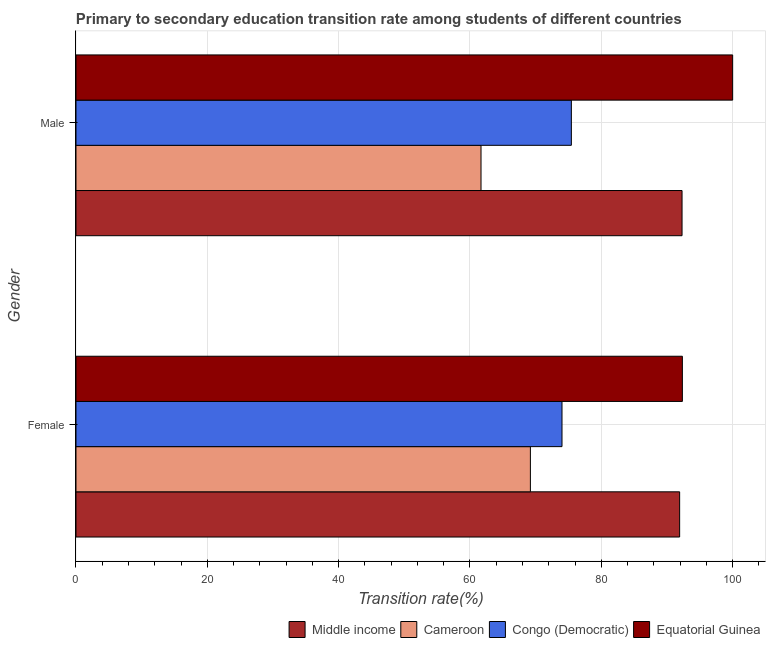Are the number of bars per tick equal to the number of legend labels?
Keep it short and to the point. Yes. How many bars are there on the 1st tick from the bottom?
Ensure brevity in your answer.  4. What is the transition rate among male students in Congo (Democratic)?
Ensure brevity in your answer.  75.44. Across all countries, what is the minimum transition rate among female students?
Your response must be concise. 69.2. In which country was the transition rate among female students maximum?
Keep it short and to the point. Equatorial Guinea. In which country was the transition rate among female students minimum?
Ensure brevity in your answer.  Cameroon. What is the total transition rate among male students in the graph?
Provide a succinct answer. 329.41. What is the difference between the transition rate among female students in Equatorial Guinea and that in Cameroon?
Keep it short and to the point. 23.14. What is the difference between the transition rate among female students in Cameroon and the transition rate among male students in Equatorial Guinea?
Your answer should be compact. -30.8. What is the average transition rate among male students per country?
Make the answer very short. 82.35. What is the difference between the transition rate among female students and transition rate among male students in Cameroon?
Your answer should be very brief. 7.52. In how many countries, is the transition rate among female students greater than 64 %?
Make the answer very short. 4. What is the ratio of the transition rate among male students in Congo (Democratic) to that in Cameroon?
Offer a very short reply. 1.22. Is the transition rate among male students in Middle income less than that in Equatorial Guinea?
Your answer should be compact. Yes. In how many countries, is the transition rate among male students greater than the average transition rate among male students taken over all countries?
Keep it short and to the point. 2. What does the 3rd bar from the top in Female represents?
Give a very brief answer. Cameroon. What does the 2nd bar from the bottom in Male represents?
Your answer should be compact. Cameroon. What is the difference between two consecutive major ticks on the X-axis?
Keep it short and to the point. 20. Where does the legend appear in the graph?
Keep it short and to the point. Bottom right. How many legend labels are there?
Offer a very short reply. 4. What is the title of the graph?
Your response must be concise. Primary to secondary education transition rate among students of different countries. Does "Europe(all income levels)" appear as one of the legend labels in the graph?
Keep it short and to the point. No. What is the label or title of the X-axis?
Your answer should be very brief. Transition rate(%). What is the Transition rate(%) in Middle income in Female?
Offer a terse response. 91.93. What is the Transition rate(%) of Cameroon in Female?
Keep it short and to the point. 69.2. What is the Transition rate(%) of Congo (Democratic) in Female?
Ensure brevity in your answer.  74.01. What is the Transition rate(%) in Equatorial Guinea in Female?
Offer a very short reply. 92.34. What is the Transition rate(%) of Middle income in Male?
Provide a short and direct response. 92.29. What is the Transition rate(%) of Cameroon in Male?
Ensure brevity in your answer.  61.68. What is the Transition rate(%) of Congo (Democratic) in Male?
Your response must be concise. 75.44. Across all Gender, what is the maximum Transition rate(%) in Middle income?
Offer a very short reply. 92.29. Across all Gender, what is the maximum Transition rate(%) in Cameroon?
Keep it short and to the point. 69.2. Across all Gender, what is the maximum Transition rate(%) in Congo (Democratic)?
Offer a terse response. 75.44. Across all Gender, what is the maximum Transition rate(%) of Equatorial Guinea?
Make the answer very short. 100. Across all Gender, what is the minimum Transition rate(%) of Middle income?
Offer a very short reply. 91.93. Across all Gender, what is the minimum Transition rate(%) in Cameroon?
Offer a very short reply. 61.68. Across all Gender, what is the minimum Transition rate(%) of Congo (Democratic)?
Give a very brief answer. 74.01. Across all Gender, what is the minimum Transition rate(%) in Equatorial Guinea?
Keep it short and to the point. 92.34. What is the total Transition rate(%) in Middle income in the graph?
Keep it short and to the point. 184.22. What is the total Transition rate(%) in Cameroon in the graph?
Make the answer very short. 130.88. What is the total Transition rate(%) in Congo (Democratic) in the graph?
Provide a succinct answer. 149.45. What is the total Transition rate(%) of Equatorial Guinea in the graph?
Your response must be concise. 192.34. What is the difference between the Transition rate(%) of Middle income in Female and that in Male?
Your answer should be compact. -0.36. What is the difference between the Transition rate(%) in Cameroon in Female and that in Male?
Provide a short and direct response. 7.52. What is the difference between the Transition rate(%) in Congo (Democratic) in Female and that in Male?
Provide a short and direct response. -1.43. What is the difference between the Transition rate(%) of Equatorial Guinea in Female and that in Male?
Offer a terse response. -7.66. What is the difference between the Transition rate(%) of Middle income in Female and the Transition rate(%) of Cameroon in Male?
Provide a succinct answer. 30.25. What is the difference between the Transition rate(%) of Middle income in Female and the Transition rate(%) of Congo (Democratic) in Male?
Your response must be concise. 16.49. What is the difference between the Transition rate(%) in Middle income in Female and the Transition rate(%) in Equatorial Guinea in Male?
Provide a short and direct response. -8.07. What is the difference between the Transition rate(%) of Cameroon in Female and the Transition rate(%) of Congo (Democratic) in Male?
Offer a very short reply. -6.24. What is the difference between the Transition rate(%) of Cameroon in Female and the Transition rate(%) of Equatorial Guinea in Male?
Give a very brief answer. -30.8. What is the difference between the Transition rate(%) in Congo (Democratic) in Female and the Transition rate(%) in Equatorial Guinea in Male?
Provide a short and direct response. -25.99. What is the average Transition rate(%) in Middle income per Gender?
Make the answer very short. 92.11. What is the average Transition rate(%) in Cameroon per Gender?
Keep it short and to the point. 65.44. What is the average Transition rate(%) in Congo (Democratic) per Gender?
Your answer should be very brief. 74.72. What is the average Transition rate(%) in Equatorial Guinea per Gender?
Your response must be concise. 96.17. What is the difference between the Transition rate(%) in Middle income and Transition rate(%) in Cameroon in Female?
Your answer should be very brief. 22.73. What is the difference between the Transition rate(%) in Middle income and Transition rate(%) in Congo (Democratic) in Female?
Your response must be concise. 17.92. What is the difference between the Transition rate(%) in Middle income and Transition rate(%) in Equatorial Guinea in Female?
Your response must be concise. -0.42. What is the difference between the Transition rate(%) in Cameroon and Transition rate(%) in Congo (Democratic) in Female?
Your answer should be compact. -4.81. What is the difference between the Transition rate(%) of Cameroon and Transition rate(%) of Equatorial Guinea in Female?
Give a very brief answer. -23.14. What is the difference between the Transition rate(%) of Congo (Democratic) and Transition rate(%) of Equatorial Guinea in Female?
Offer a very short reply. -18.33. What is the difference between the Transition rate(%) in Middle income and Transition rate(%) in Cameroon in Male?
Provide a short and direct response. 30.61. What is the difference between the Transition rate(%) of Middle income and Transition rate(%) of Congo (Democratic) in Male?
Your answer should be compact. 16.85. What is the difference between the Transition rate(%) in Middle income and Transition rate(%) in Equatorial Guinea in Male?
Offer a terse response. -7.71. What is the difference between the Transition rate(%) of Cameroon and Transition rate(%) of Congo (Democratic) in Male?
Make the answer very short. -13.76. What is the difference between the Transition rate(%) in Cameroon and Transition rate(%) in Equatorial Guinea in Male?
Your answer should be very brief. -38.32. What is the difference between the Transition rate(%) in Congo (Democratic) and Transition rate(%) in Equatorial Guinea in Male?
Offer a terse response. -24.56. What is the ratio of the Transition rate(%) in Cameroon in Female to that in Male?
Provide a succinct answer. 1.12. What is the ratio of the Transition rate(%) of Congo (Democratic) in Female to that in Male?
Provide a short and direct response. 0.98. What is the ratio of the Transition rate(%) of Equatorial Guinea in Female to that in Male?
Your answer should be very brief. 0.92. What is the difference between the highest and the second highest Transition rate(%) of Middle income?
Your answer should be very brief. 0.36. What is the difference between the highest and the second highest Transition rate(%) of Cameroon?
Your answer should be very brief. 7.52. What is the difference between the highest and the second highest Transition rate(%) of Congo (Democratic)?
Provide a succinct answer. 1.43. What is the difference between the highest and the second highest Transition rate(%) in Equatorial Guinea?
Offer a terse response. 7.66. What is the difference between the highest and the lowest Transition rate(%) in Middle income?
Offer a very short reply. 0.36. What is the difference between the highest and the lowest Transition rate(%) in Cameroon?
Your answer should be compact. 7.52. What is the difference between the highest and the lowest Transition rate(%) in Congo (Democratic)?
Keep it short and to the point. 1.43. What is the difference between the highest and the lowest Transition rate(%) in Equatorial Guinea?
Your answer should be compact. 7.66. 